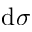Convert formula to latex. <formula><loc_0><loc_0><loc_500><loc_500>d \sigma</formula> 